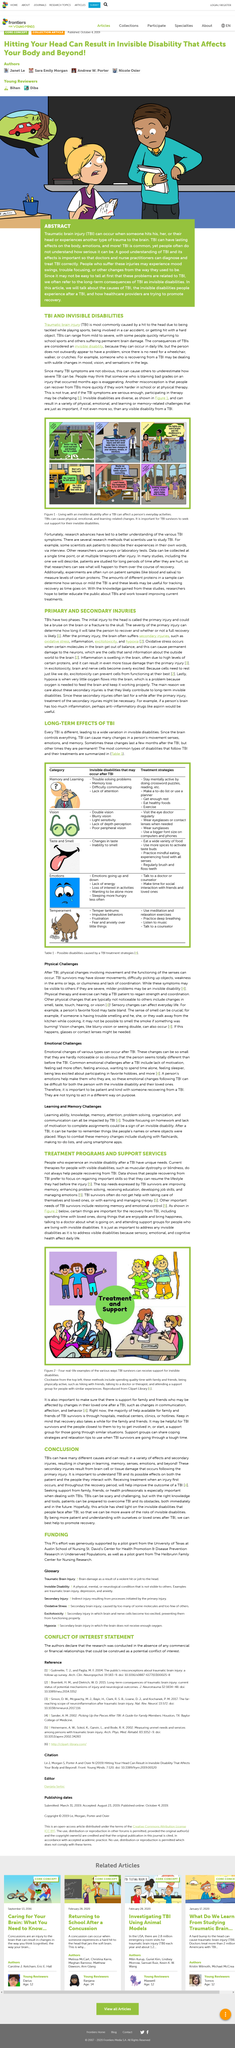Specify some key components in this picture. Traumatic brain injury is commonly referred to as TBI. This article is about TBC and invisible disabilities, and seeks to educate readers about these topics and encourage empathy and understanding for those affected by invisible disabilities. There are suggested ways of staying mentally active, such as doing crossword puzzles and reading. The first phase of TBIs is characterized by either a bruise on the brain or a fracture to the skull. Excitotoxicity can prevent cells from functioning at their best by causing cell damage and death. 